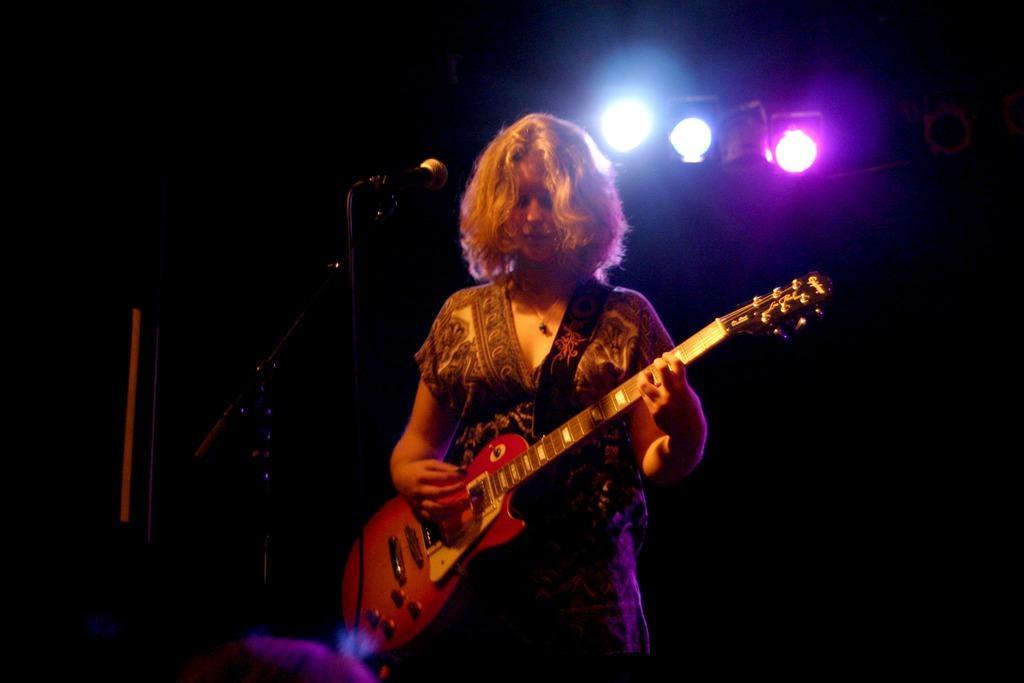Describe this image in one or two sentences. There is a lady standing and she is playing guitar. In front of her there is a mic. And on the top there are three lights. 